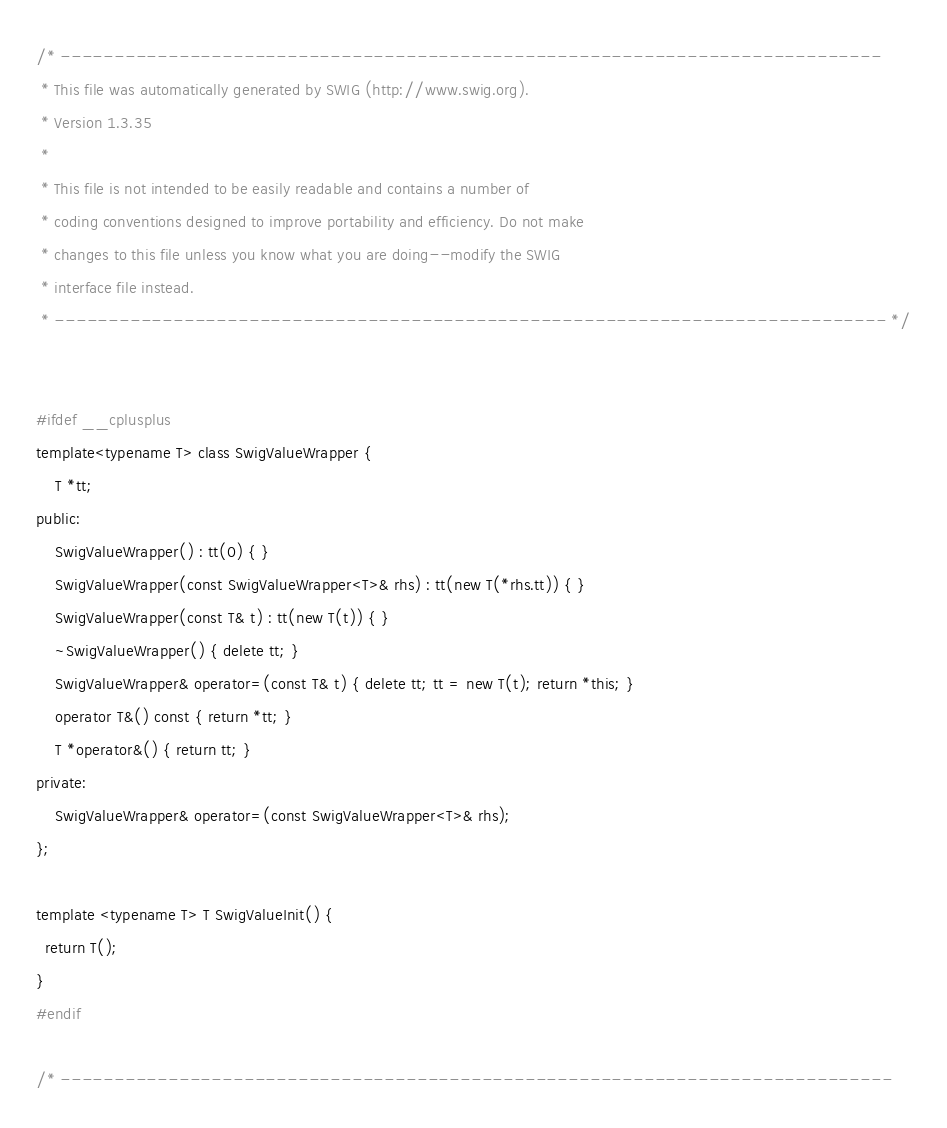Convert code to text. <code><loc_0><loc_0><loc_500><loc_500><_C_>/* ----------------------------------------------------------------------------
 * This file was automatically generated by SWIG (http://www.swig.org).
 * Version 1.3.35
 * 
 * This file is not intended to be easily readable and contains a number of 
 * coding conventions designed to improve portability and efficiency. Do not make
 * changes to this file unless you know what you are doing--modify the SWIG 
 * interface file instead. 
 * ----------------------------------------------------------------------------- */


#ifdef __cplusplus
template<typename T> class SwigValueWrapper {
    T *tt;
public:
    SwigValueWrapper() : tt(0) { }
    SwigValueWrapper(const SwigValueWrapper<T>& rhs) : tt(new T(*rhs.tt)) { }
    SwigValueWrapper(const T& t) : tt(new T(t)) { }
    ~SwigValueWrapper() { delete tt; } 
    SwigValueWrapper& operator=(const T& t) { delete tt; tt = new T(t); return *this; }
    operator T&() const { return *tt; }
    T *operator&() { return tt; }
private:
    SwigValueWrapper& operator=(const SwigValueWrapper<T>& rhs);
};

template <typename T> T SwigValueInit() {
  return T();
}
#endif

/* -----------------------------------------------------------------------------</code> 